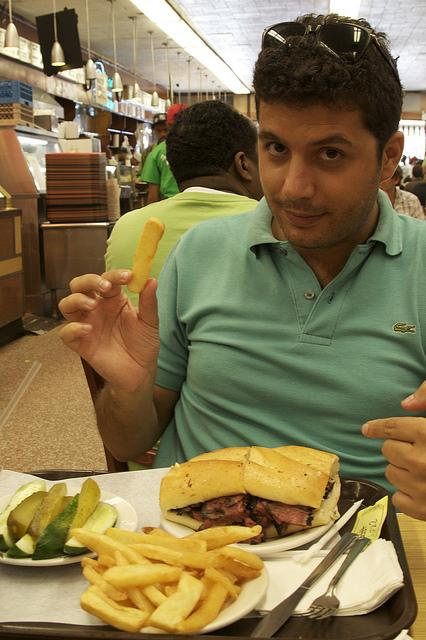The type of restaurant the man is eating at is more likely a what? Please explain your reasoning. steakhouse. The man is eating a sandwich, fries and pickles.  those are not the types of items served at a chinese, mexican or italian restaurant. 